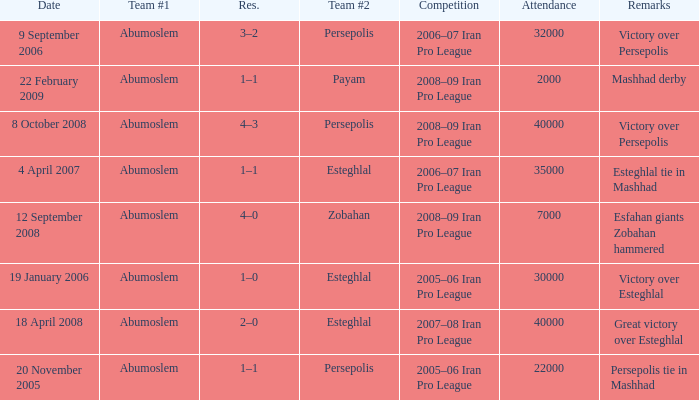What was the maximum number of attendees? 40000.0. 